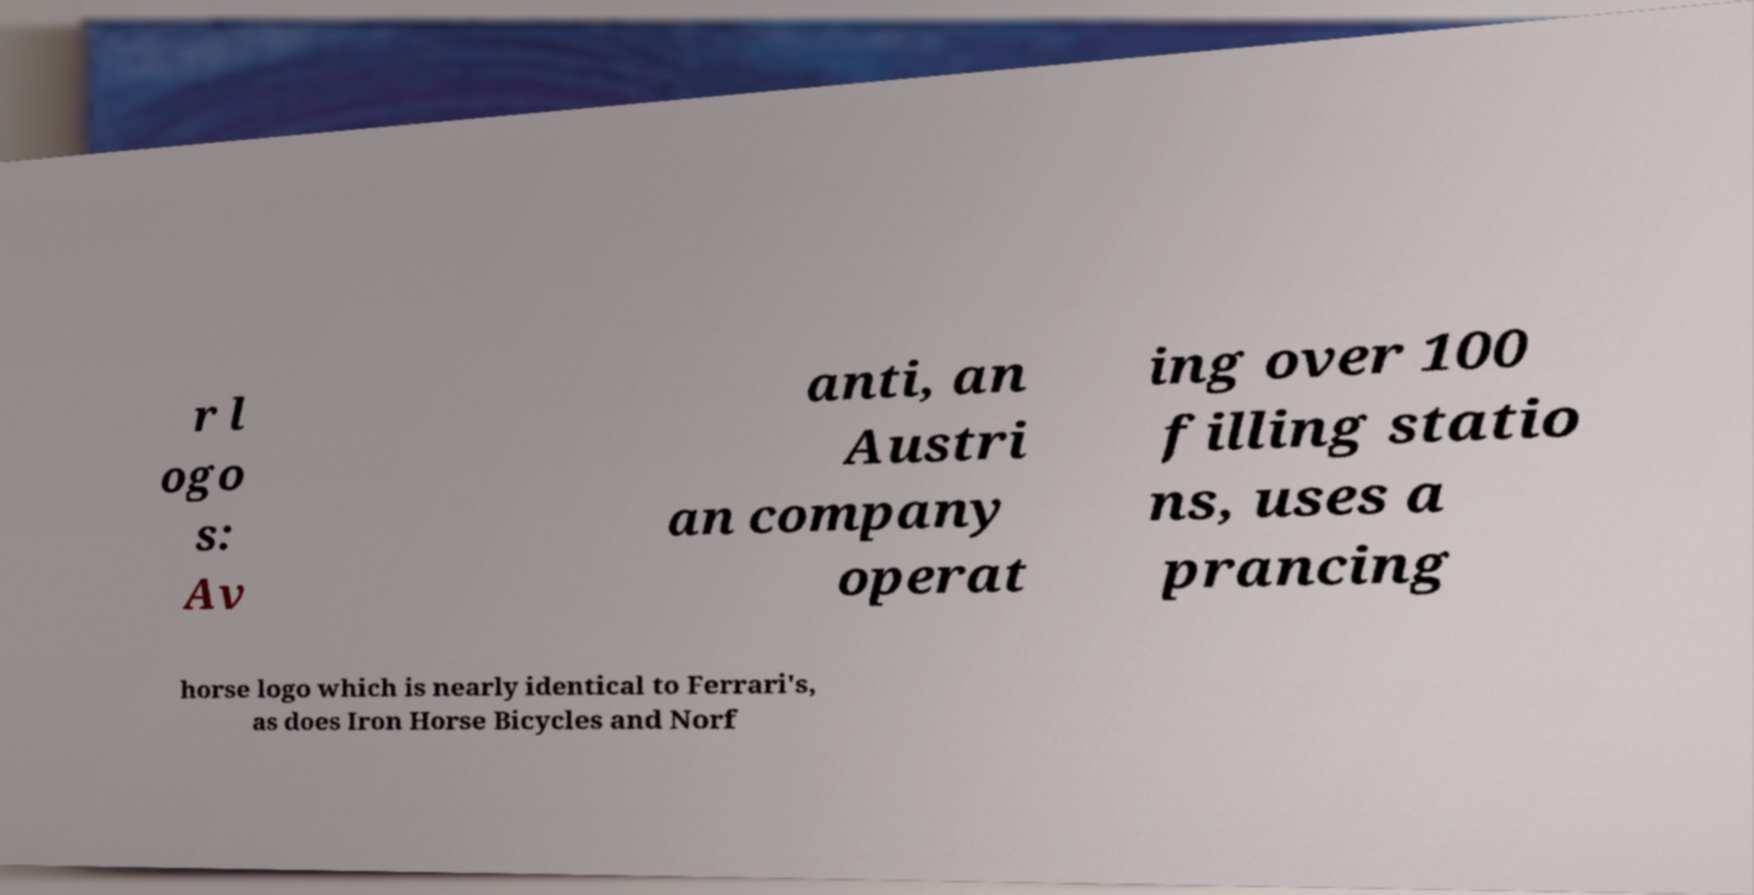What messages or text are displayed in this image? I need them in a readable, typed format. r l ogo s: Av anti, an Austri an company operat ing over 100 filling statio ns, uses a prancing horse logo which is nearly identical to Ferrari's, as does Iron Horse Bicycles and Norf 